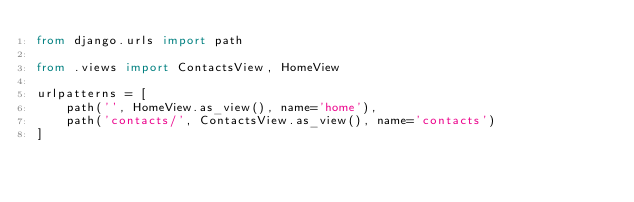Convert code to text. <code><loc_0><loc_0><loc_500><loc_500><_Python_>from django.urls import path

from .views import ContactsView, HomeView

urlpatterns = [
    path('', HomeView.as_view(), name='home'),
    path('contacts/', ContactsView.as_view(), name='contacts')
]
</code> 